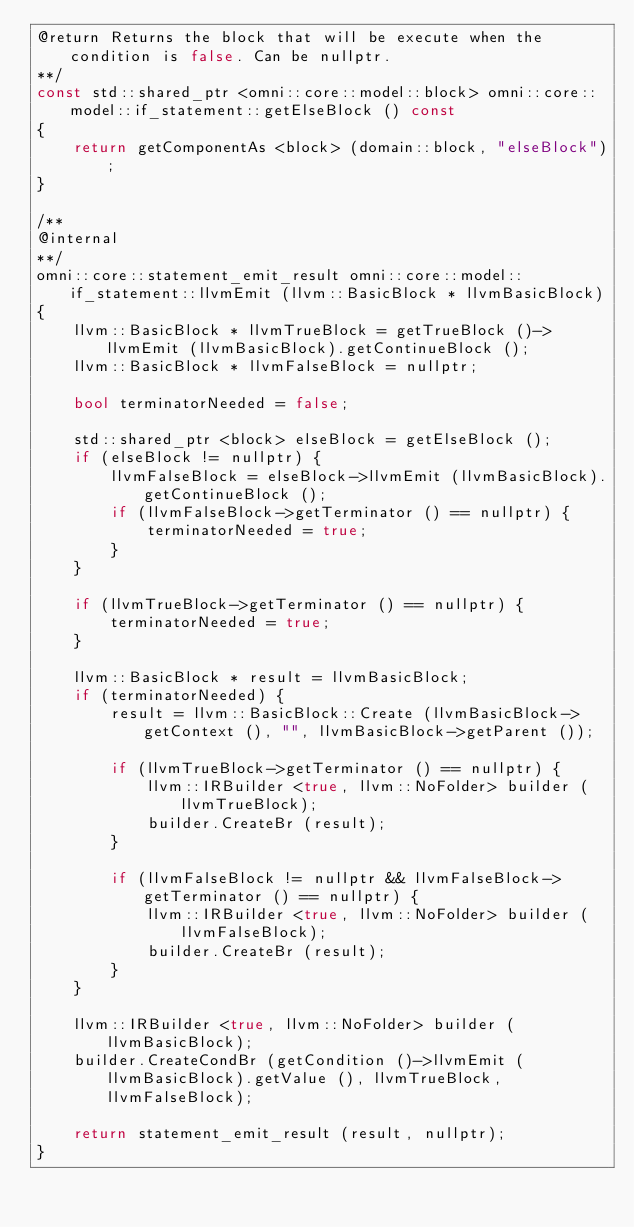Convert code to text. <code><loc_0><loc_0><loc_500><loc_500><_C++_>@return Returns the block that will be execute when the condition is false. Can be nullptr.
**/
const std::shared_ptr <omni::core::model::block> omni::core::model::if_statement::getElseBlock () const
{
    return getComponentAs <block> (domain::block, "elseBlock");
}

/**
@internal
**/
omni::core::statement_emit_result omni::core::model::if_statement::llvmEmit (llvm::BasicBlock * llvmBasicBlock)
{
    llvm::BasicBlock * llvmTrueBlock = getTrueBlock ()->llvmEmit (llvmBasicBlock).getContinueBlock ();
    llvm::BasicBlock * llvmFalseBlock = nullptr;

    bool terminatorNeeded = false;

    std::shared_ptr <block> elseBlock = getElseBlock ();
    if (elseBlock != nullptr) {
        llvmFalseBlock = elseBlock->llvmEmit (llvmBasicBlock).getContinueBlock ();
        if (llvmFalseBlock->getTerminator () == nullptr) {
            terminatorNeeded = true;
        }
    }

    if (llvmTrueBlock->getTerminator () == nullptr) {
        terminatorNeeded = true;
    }

    llvm::BasicBlock * result = llvmBasicBlock;
    if (terminatorNeeded) {
        result = llvm::BasicBlock::Create (llvmBasicBlock->getContext (), "", llvmBasicBlock->getParent ());

        if (llvmTrueBlock->getTerminator () == nullptr) {
            llvm::IRBuilder <true, llvm::NoFolder> builder (llvmTrueBlock);
            builder.CreateBr (result);
        }

        if (llvmFalseBlock != nullptr && llvmFalseBlock->getTerminator () == nullptr) {
            llvm::IRBuilder <true, llvm::NoFolder> builder (llvmFalseBlock);
            builder.CreateBr (result);
        }
    }

    llvm::IRBuilder <true, llvm::NoFolder> builder (llvmBasicBlock);
    builder.CreateCondBr (getCondition ()->llvmEmit (llvmBasicBlock).getValue (), llvmTrueBlock, llvmFalseBlock);

    return statement_emit_result (result, nullptr);
}
</code> 